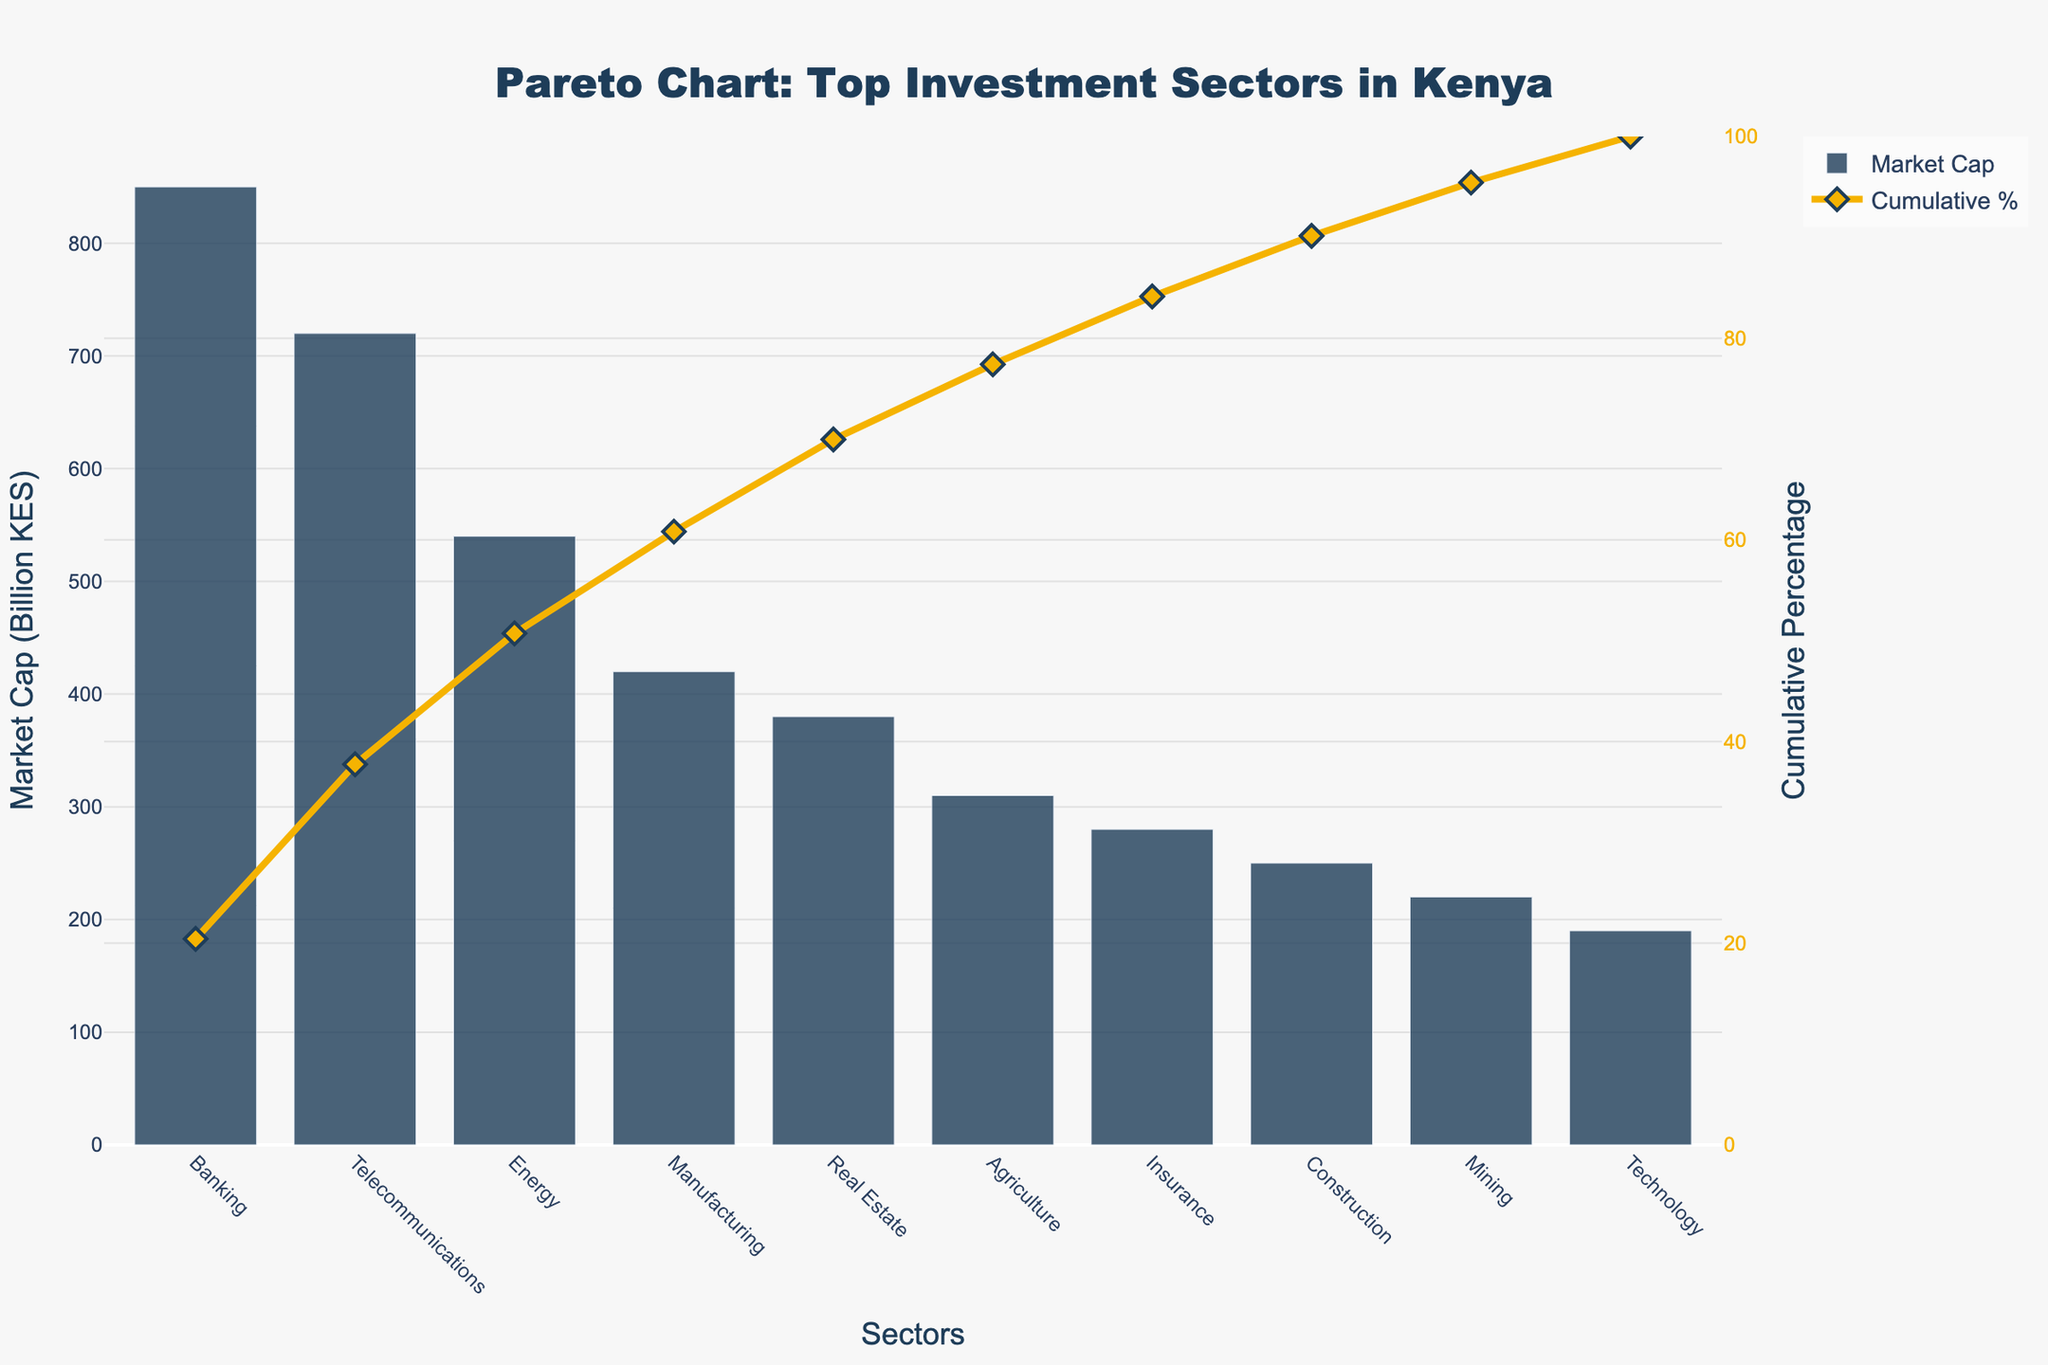what is the Market Cap of the Banking sector? From the figure, the bar representing the Banking sector shows a height corresponding to its market cap. According to the data provided, the Market Cap is clearly labeled.
Answer: 850 Billion KES What color represents the Market Cap bars in the chart? From the figure, the bars representing the Market Cap are uniformly colored. Observation of the color helps identify it.
Answer: Dark Blue Which sector has the second-highest Market Cap, and what is its value? The bar heights in the figure help identify the second-highest point. The second-highest bar corresponds to the Telecommunications sector. According to the data, its Market Cap is indicated.
Answer: Telecommunications, 720 Billion KES What is the title of the figure? The top of the figure contains the title clearly visible and readable, giving insight into the focus of the chart.
Answer: Pareto Chart: Top Investment Sectors in Kenya What is the cumulative percentage after the top three sectors? By examining the line plot in the figure, the cumulative percentage after Banking, Telecommunications, and Energy sectors can be read directly from the y2 axis. The sum of their individual market caps is used to find this value.
Answer: 70.89% Which sector has the largest growth rate? The provided data includes growth rates for each sector. By identifying the sector with the highest percentage, we find the answer.
Answer: Technology What is the cumulative percentage exactly on the Real Estate sector's data point? By locating the Real Estate sector's data point on the x-axis and referring to the corresponding y2 axis value, the cumulative percentage at this point can be determined.
Answer: 81.68% Which sector has the lowest Market Cap, and what is its cumulative percentage value? By comparing the heights of the bars, the smallest bar, representing the lowest Market Cap, can be identified. Reading the corresponding y2 axis value gives the cumulative percentage.
Answer: Technology, 100% How does the Market Cap of the Construction sector compare to that of Agriculture? Referring to the data or heights of the bars, we can see the exact Market Cap of each sector and compare directly.
Answer: Agriculture is higher than Construction by 60 billion KES What are the cumulative percentage values for the Banking and Technology sectors? By examining the line plot from the beginning point (Banking) and end point (Technology) and reading the y2 axis, we get the required cumulative percentage values.
Answer: Banking: 25.04%, Technology: 100% 